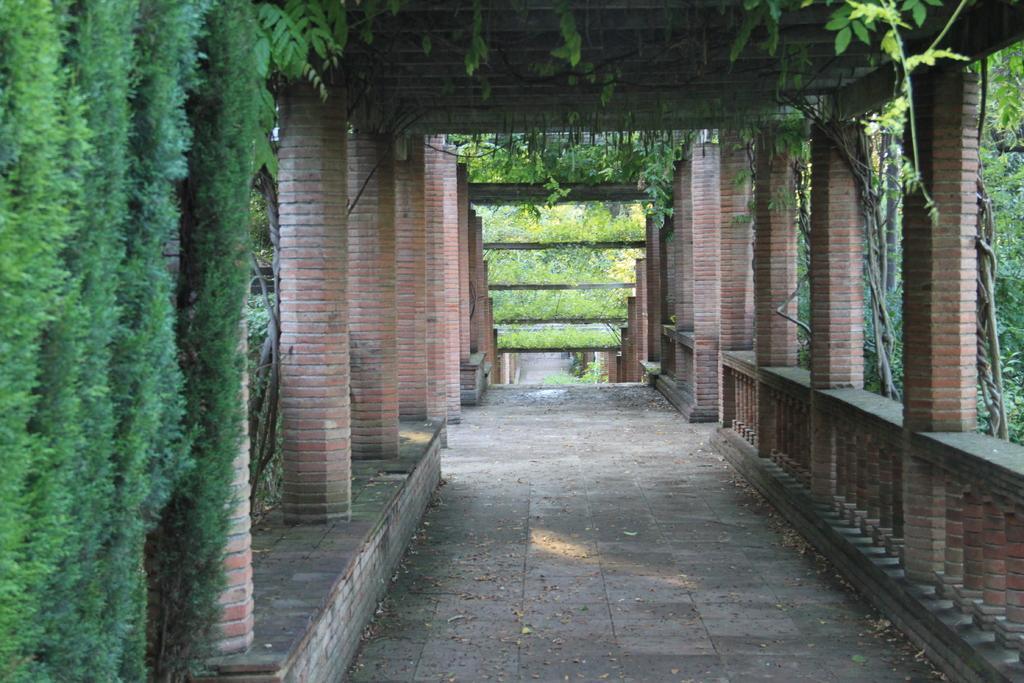Describe this image in one or two sentences. In this image we can see pillars, wall, railing, floor and roof. On the left side we can see creepers. In the background there are plants. 